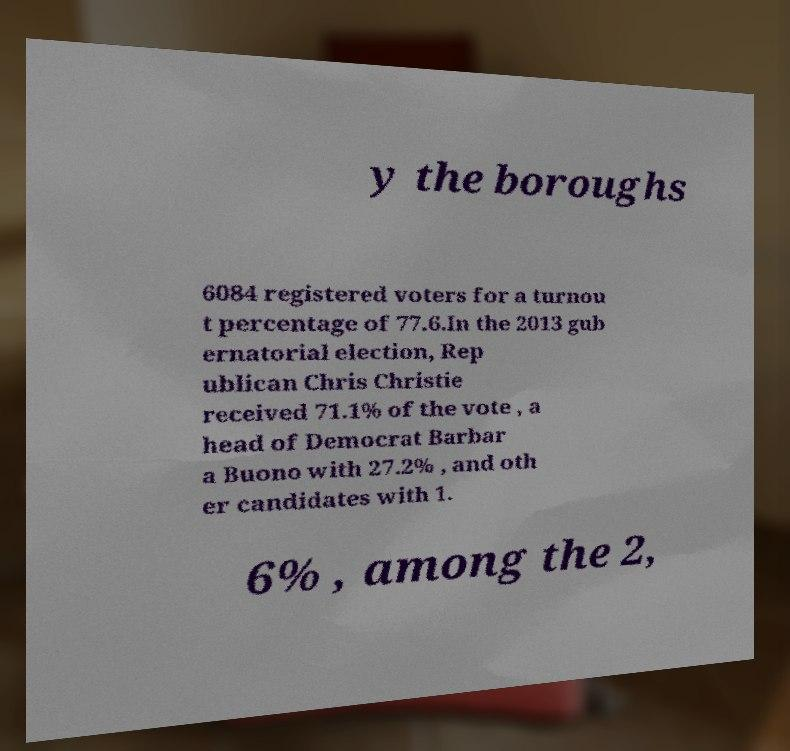Can you read and provide the text displayed in the image?This photo seems to have some interesting text. Can you extract and type it out for me? y the boroughs 6084 registered voters for a turnou t percentage of 77.6.In the 2013 gub ernatorial election, Rep ublican Chris Christie received 71.1% of the vote , a head of Democrat Barbar a Buono with 27.2% , and oth er candidates with 1. 6% , among the 2, 